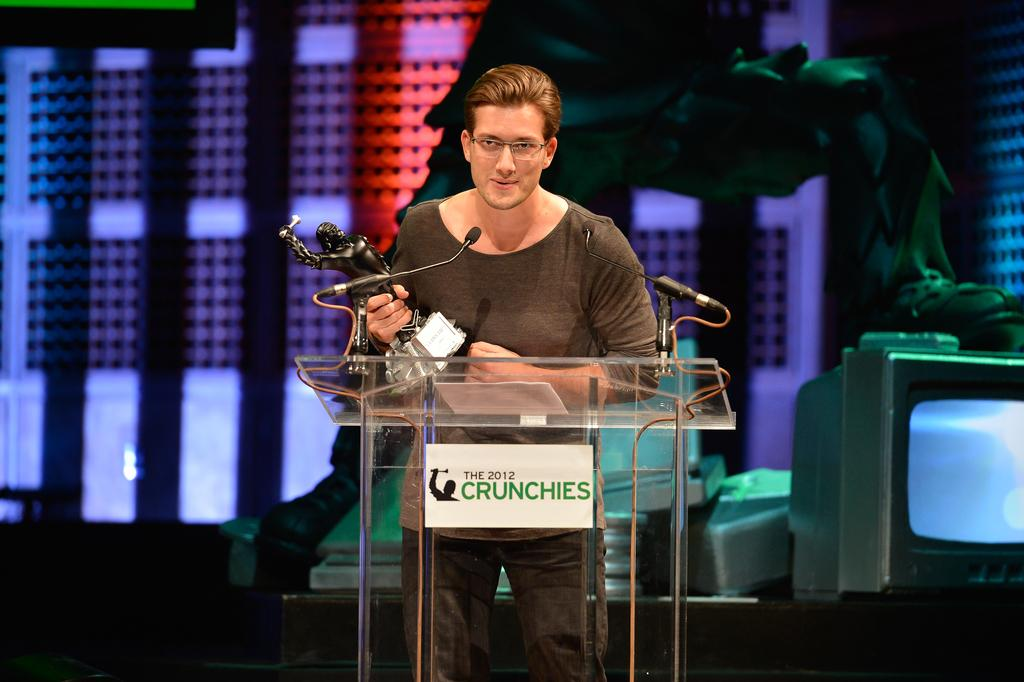<image>
Give a short and clear explanation of the subsequent image. A man holding a trophy speaks into a microphone at the Crunchies awards. 